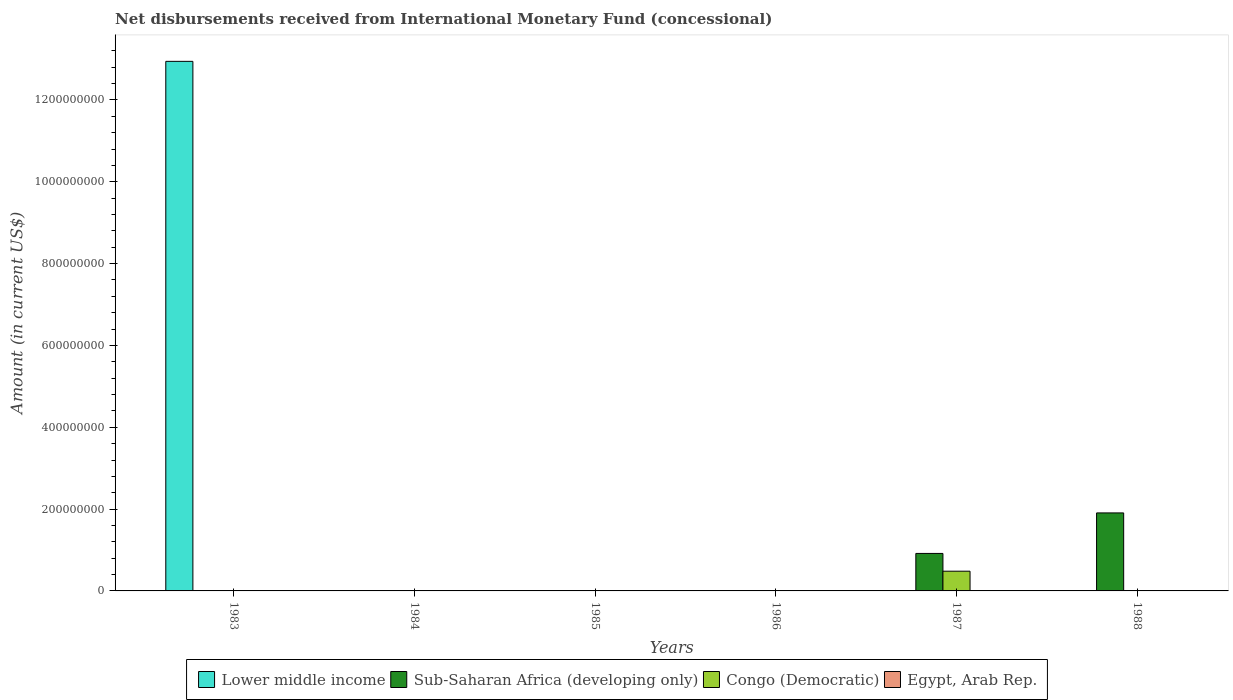Are the number of bars on each tick of the X-axis equal?
Make the answer very short. No. How many bars are there on the 2nd tick from the left?
Give a very brief answer. 0. How many bars are there on the 4th tick from the right?
Your answer should be compact. 0. Across all years, what is the maximum amount of disbursements received from International Monetary Fund in Lower middle income?
Keep it short and to the point. 1.29e+09. What is the total amount of disbursements received from International Monetary Fund in Egypt, Arab Rep. in the graph?
Your answer should be very brief. 0. What is the difference between the amount of disbursements received from International Monetary Fund in Sub-Saharan Africa (developing only) in 1987 and the amount of disbursements received from International Monetary Fund in Egypt, Arab Rep. in 1985?
Make the answer very short. 9.16e+07. What is the average amount of disbursements received from International Monetary Fund in Sub-Saharan Africa (developing only) per year?
Give a very brief answer. 4.70e+07. In how many years, is the amount of disbursements received from International Monetary Fund in Sub-Saharan Africa (developing only) greater than 1280000000 US$?
Give a very brief answer. 0. What is the difference between the highest and the lowest amount of disbursements received from International Monetary Fund in Sub-Saharan Africa (developing only)?
Provide a short and direct response. 1.91e+08. In how many years, is the amount of disbursements received from International Monetary Fund in Congo (Democratic) greater than the average amount of disbursements received from International Monetary Fund in Congo (Democratic) taken over all years?
Ensure brevity in your answer.  1. Is it the case that in every year, the sum of the amount of disbursements received from International Monetary Fund in Egypt, Arab Rep. and amount of disbursements received from International Monetary Fund in Sub-Saharan Africa (developing only) is greater than the sum of amount of disbursements received from International Monetary Fund in Congo (Democratic) and amount of disbursements received from International Monetary Fund in Lower middle income?
Your answer should be very brief. No. Is it the case that in every year, the sum of the amount of disbursements received from International Monetary Fund in Egypt, Arab Rep. and amount of disbursements received from International Monetary Fund in Lower middle income is greater than the amount of disbursements received from International Monetary Fund in Sub-Saharan Africa (developing only)?
Keep it short and to the point. No. Are all the bars in the graph horizontal?
Offer a very short reply. No. What is the difference between two consecutive major ticks on the Y-axis?
Your answer should be very brief. 2.00e+08. Are the values on the major ticks of Y-axis written in scientific E-notation?
Give a very brief answer. No. Where does the legend appear in the graph?
Offer a terse response. Bottom center. How many legend labels are there?
Provide a succinct answer. 4. What is the title of the graph?
Give a very brief answer. Net disbursements received from International Monetary Fund (concessional). Does "Bahamas" appear as one of the legend labels in the graph?
Provide a succinct answer. No. What is the label or title of the Y-axis?
Keep it short and to the point. Amount (in current US$). What is the Amount (in current US$) of Lower middle income in 1983?
Your answer should be very brief. 1.29e+09. What is the Amount (in current US$) of Congo (Democratic) in 1983?
Ensure brevity in your answer.  0. What is the Amount (in current US$) of Egypt, Arab Rep. in 1984?
Give a very brief answer. 0. What is the Amount (in current US$) in Lower middle income in 1985?
Ensure brevity in your answer.  0. What is the Amount (in current US$) in Sub-Saharan Africa (developing only) in 1985?
Ensure brevity in your answer.  0. What is the Amount (in current US$) of Congo (Democratic) in 1985?
Offer a terse response. 0. What is the Amount (in current US$) of Egypt, Arab Rep. in 1985?
Give a very brief answer. 0. What is the Amount (in current US$) of Sub-Saharan Africa (developing only) in 1986?
Your answer should be very brief. 0. What is the Amount (in current US$) in Egypt, Arab Rep. in 1986?
Ensure brevity in your answer.  0. What is the Amount (in current US$) in Sub-Saharan Africa (developing only) in 1987?
Your answer should be compact. 9.16e+07. What is the Amount (in current US$) in Congo (Democratic) in 1987?
Your answer should be compact. 4.82e+07. What is the Amount (in current US$) in Sub-Saharan Africa (developing only) in 1988?
Provide a succinct answer. 1.91e+08. What is the Amount (in current US$) in Congo (Democratic) in 1988?
Provide a short and direct response. 0. Across all years, what is the maximum Amount (in current US$) of Lower middle income?
Your response must be concise. 1.29e+09. Across all years, what is the maximum Amount (in current US$) in Sub-Saharan Africa (developing only)?
Give a very brief answer. 1.91e+08. Across all years, what is the maximum Amount (in current US$) of Congo (Democratic)?
Provide a short and direct response. 4.82e+07. Across all years, what is the minimum Amount (in current US$) of Sub-Saharan Africa (developing only)?
Make the answer very short. 0. What is the total Amount (in current US$) in Lower middle income in the graph?
Make the answer very short. 1.29e+09. What is the total Amount (in current US$) of Sub-Saharan Africa (developing only) in the graph?
Offer a very short reply. 2.82e+08. What is the total Amount (in current US$) of Congo (Democratic) in the graph?
Your response must be concise. 4.82e+07. What is the total Amount (in current US$) in Egypt, Arab Rep. in the graph?
Make the answer very short. 0. What is the difference between the Amount (in current US$) in Sub-Saharan Africa (developing only) in 1987 and that in 1988?
Keep it short and to the point. -9.90e+07. What is the difference between the Amount (in current US$) of Lower middle income in 1983 and the Amount (in current US$) of Sub-Saharan Africa (developing only) in 1987?
Provide a succinct answer. 1.20e+09. What is the difference between the Amount (in current US$) in Lower middle income in 1983 and the Amount (in current US$) in Congo (Democratic) in 1987?
Offer a terse response. 1.25e+09. What is the difference between the Amount (in current US$) in Lower middle income in 1983 and the Amount (in current US$) in Sub-Saharan Africa (developing only) in 1988?
Offer a terse response. 1.10e+09. What is the average Amount (in current US$) of Lower middle income per year?
Your answer should be very brief. 2.16e+08. What is the average Amount (in current US$) in Sub-Saharan Africa (developing only) per year?
Provide a succinct answer. 4.70e+07. What is the average Amount (in current US$) of Congo (Democratic) per year?
Your answer should be very brief. 8.03e+06. In the year 1987, what is the difference between the Amount (in current US$) of Sub-Saharan Africa (developing only) and Amount (in current US$) of Congo (Democratic)?
Provide a short and direct response. 4.34e+07. What is the ratio of the Amount (in current US$) of Sub-Saharan Africa (developing only) in 1987 to that in 1988?
Your response must be concise. 0.48. What is the difference between the highest and the lowest Amount (in current US$) of Lower middle income?
Give a very brief answer. 1.29e+09. What is the difference between the highest and the lowest Amount (in current US$) of Sub-Saharan Africa (developing only)?
Your answer should be compact. 1.91e+08. What is the difference between the highest and the lowest Amount (in current US$) in Congo (Democratic)?
Offer a terse response. 4.82e+07. 